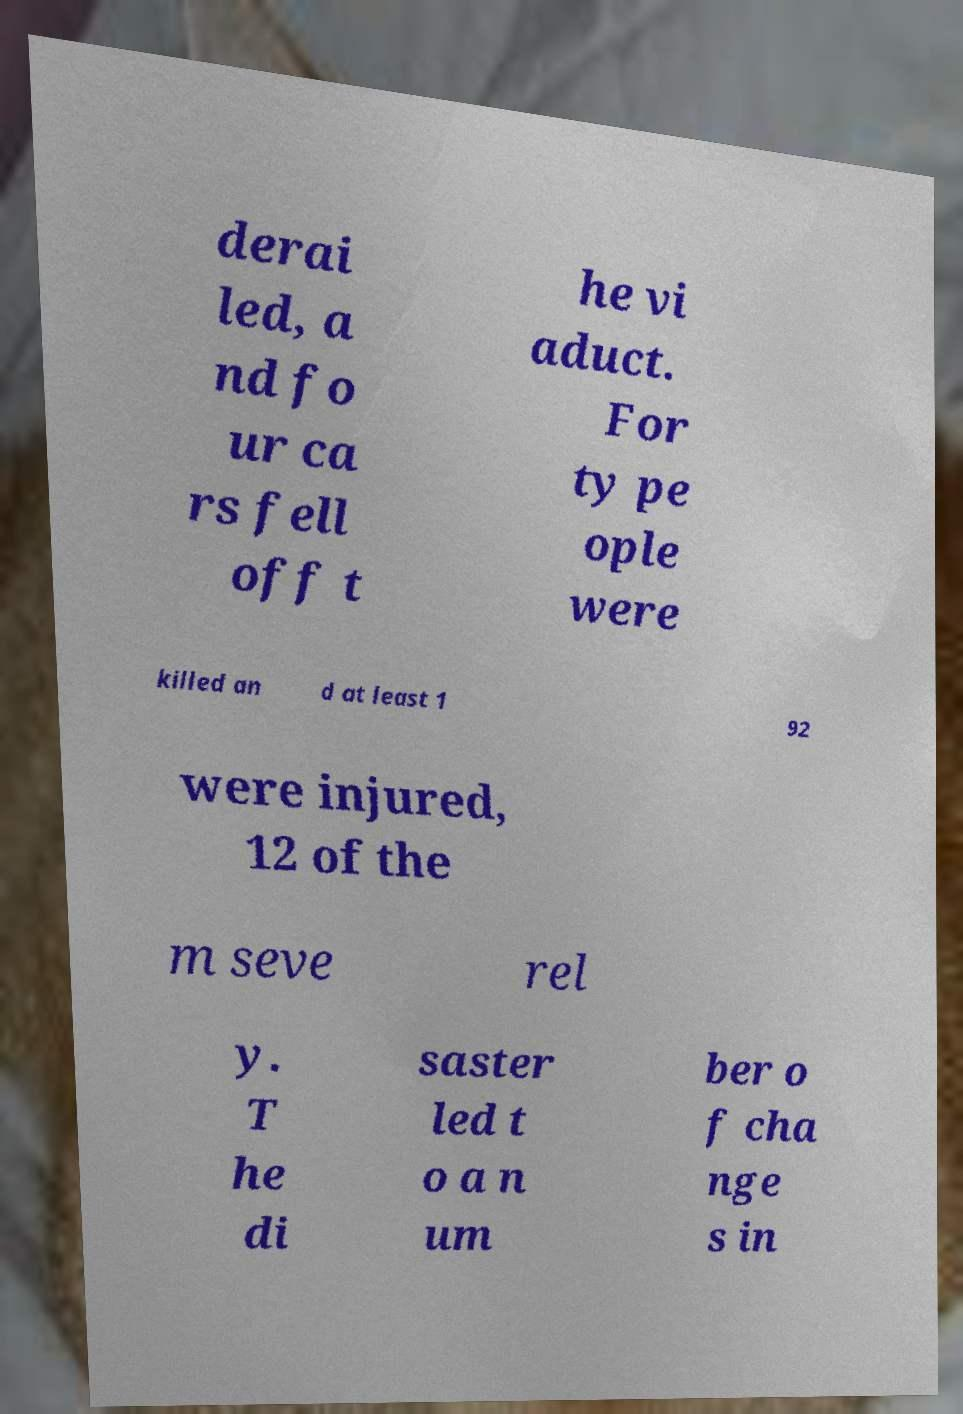Can you read and provide the text displayed in the image?This photo seems to have some interesting text. Can you extract and type it out for me? derai led, a nd fo ur ca rs fell off t he vi aduct. For ty pe ople were killed an d at least 1 92 were injured, 12 of the m seve rel y. T he di saster led t o a n um ber o f cha nge s in 